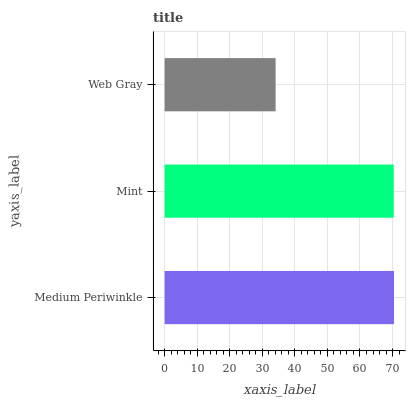Is Web Gray the minimum?
Answer yes or no. Yes. Is Medium Periwinkle the maximum?
Answer yes or no. Yes. Is Mint the minimum?
Answer yes or no. No. Is Mint the maximum?
Answer yes or no. No. Is Medium Periwinkle greater than Mint?
Answer yes or no. Yes. Is Mint less than Medium Periwinkle?
Answer yes or no. Yes. Is Mint greater than Medium Periwinkle?
Answer yes or no. No. Is Medium Periwinkle less than Mint?
Answer yes or no. No. Is Mint the high median?
Answer yes or no. Yes. Is Mint the low median?
Answer yes or no. Yes. Is Medium Periwinkle the high median?
Answer yes or no. No. Is Web Gray the low median?
Answer yes or no. No. 